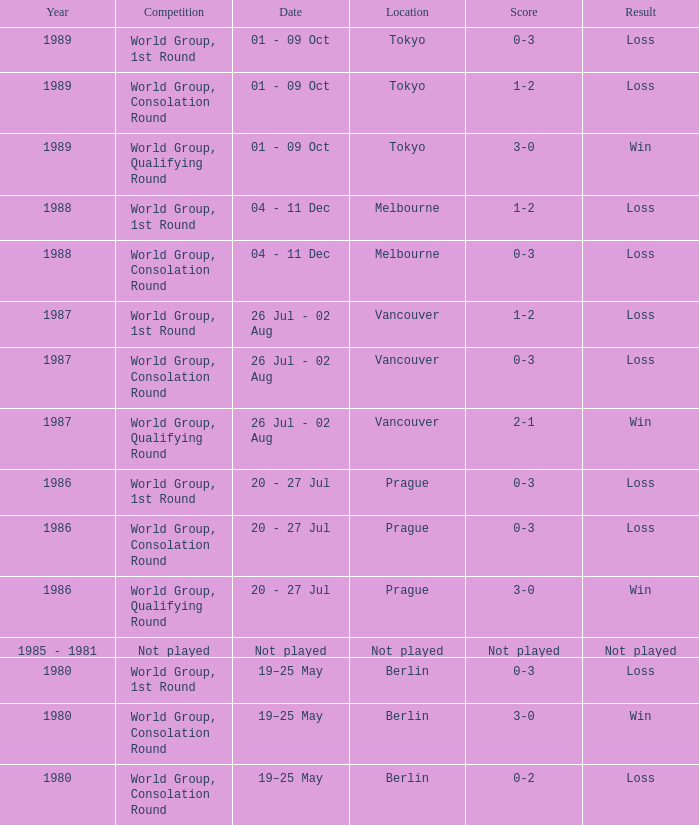What is the score when the result is loss, the year is 1980 and the competition is world group, consolation round? 0-2. 